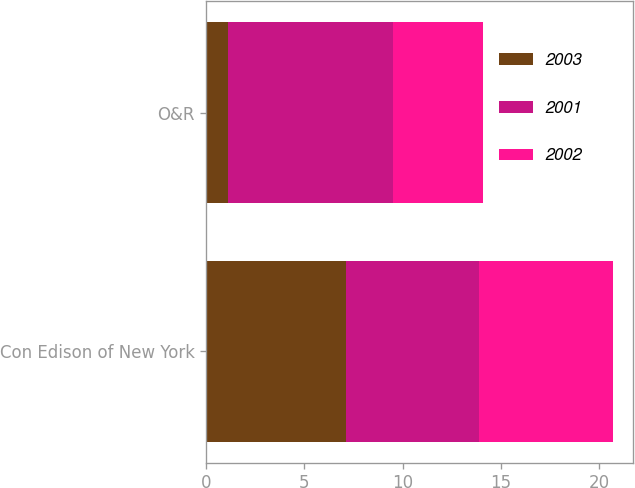<chart> <loc_0><loc_0><loc_500><loc_500><stacked_bar_chart><ecel><fcel>Con Edison of New York<fcel>O&R<nl><fcel>2003<fcel>7.1<fcel>1.1<nl><fcel>2001<fcel>6.8<fcel>8.4<nl><fcel>2002<fcel>6.8<fcel>4.6<nl></chart> 